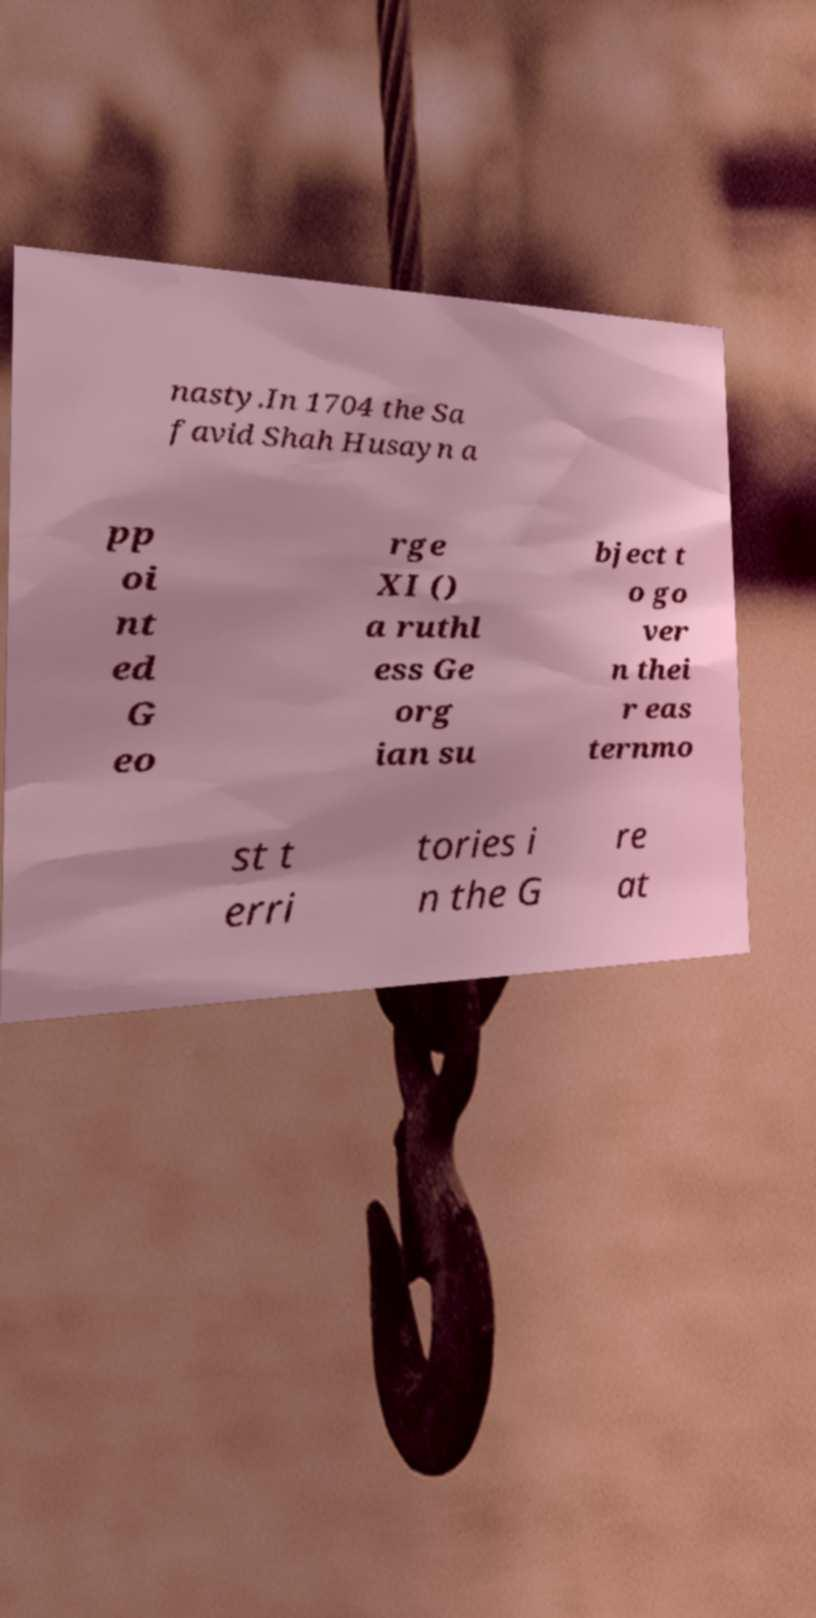I need the written content from this picture converted into text. Can you do that? nasty.In 1704 the Sa favid Shah Husayn a pp oi nt ed G eo rge XI () a ruthl ess Ge org ian su bject t o go ver n thei r eas ternmo st t erri tories i n the G re at 